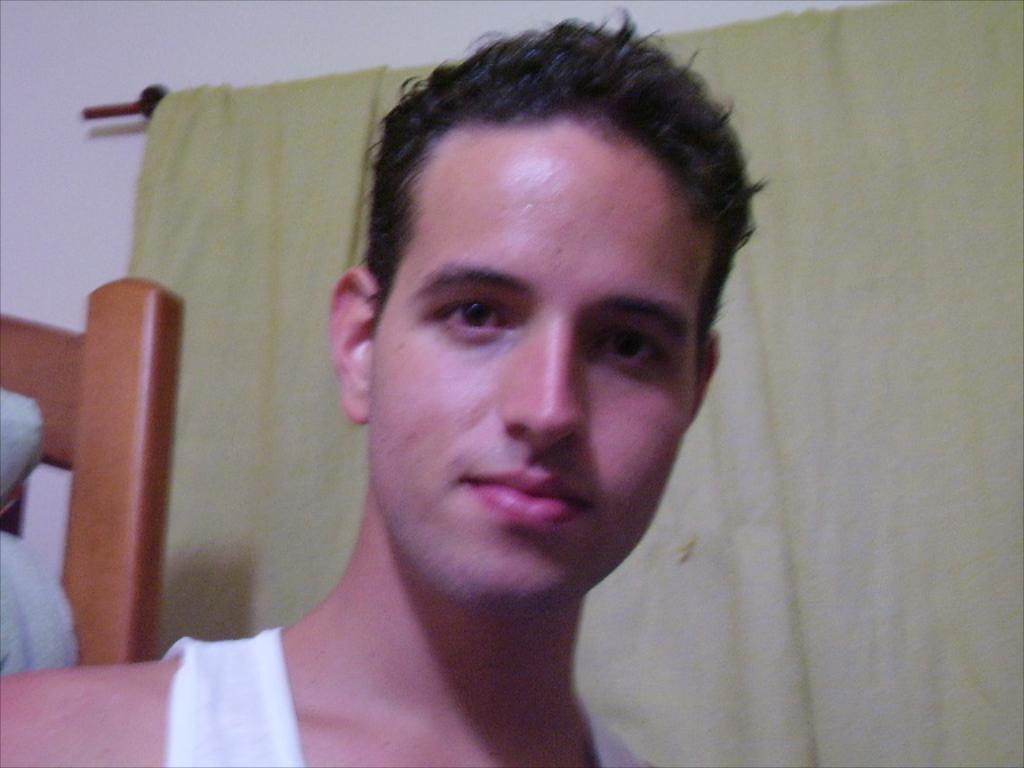Please provide a concise description of this image. In this picture we can observe a person. Behind him there is a brown color wooden furniture. We can observe a green color curtain. In the background there is a wall. 